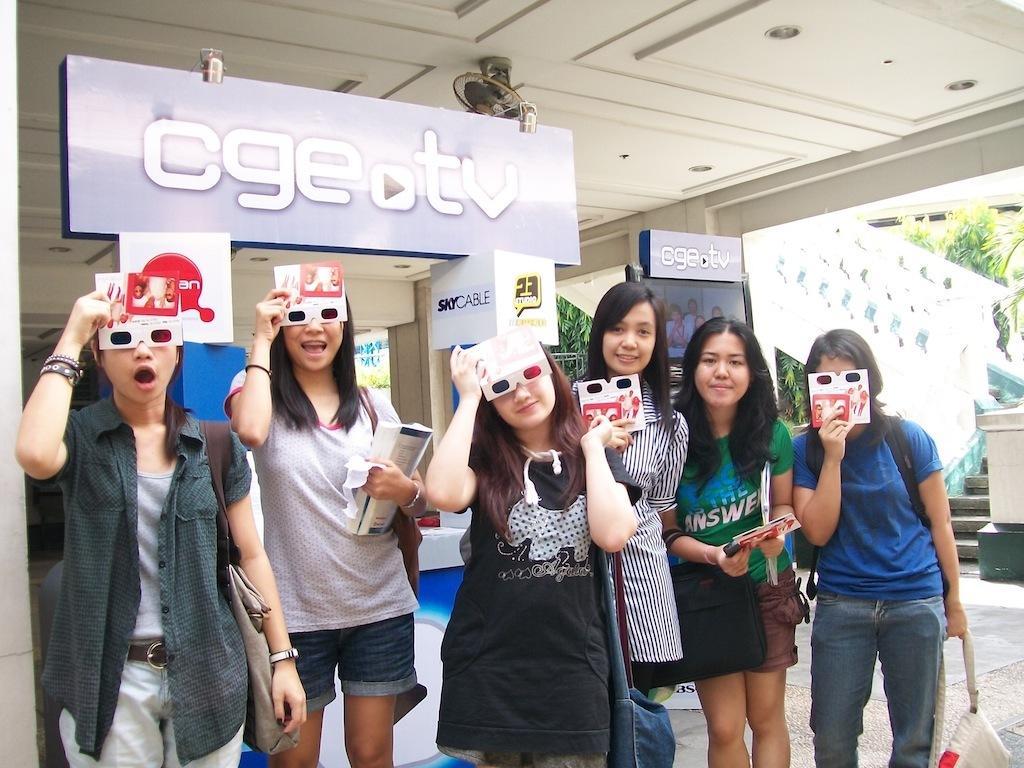Describe this image in one or two sentences. In this picture there are girls in the center of the image, by holding eye mask in their hands and there are stairs on the right side of the image, there are trees in the background area of the image and there is a poster at the top side of the image. 